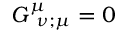<formula> <loc_0><loc_0><loc_500><loc_500>G _ { { \, \nu } ; \mu } ^ { \mu } = 0</formula> 